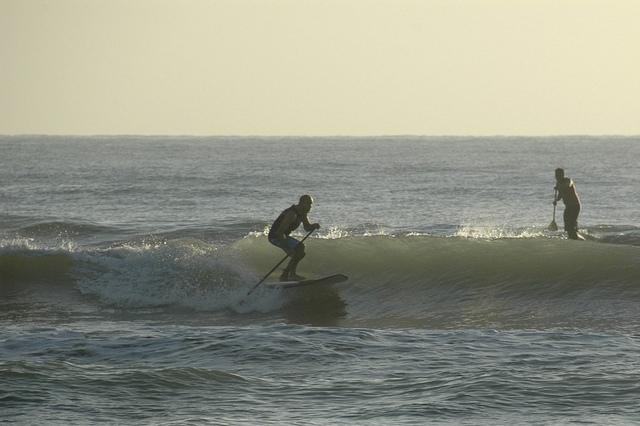What type of equipment are the people holding? Please explain your reasoning. oars. They are using the tool to move their boards through the water. 